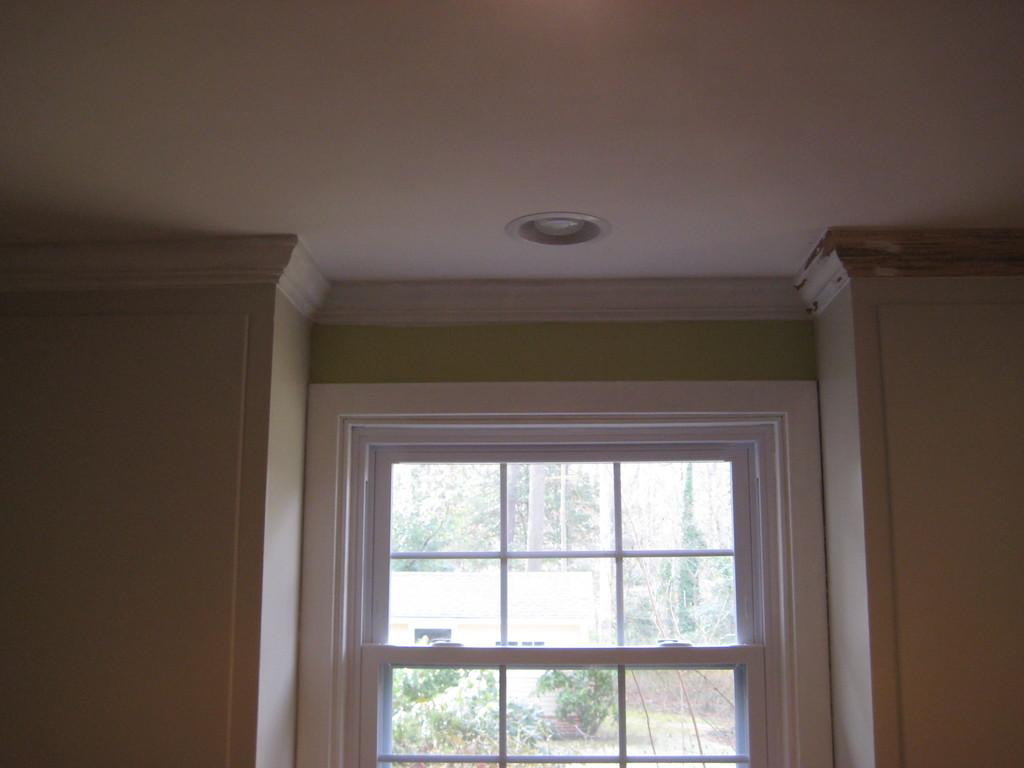What is located in the center of the image? There is a window in the center of the image. What can be seen through the window? Trees are visible through the window glass. What type of structure is present in the image? There is a wall in the image. Where is the light source located in the image? There is a light at the top of the image. What type of beef is being prepared by the doctor in the image? There is no doctor or beef present in the image. 